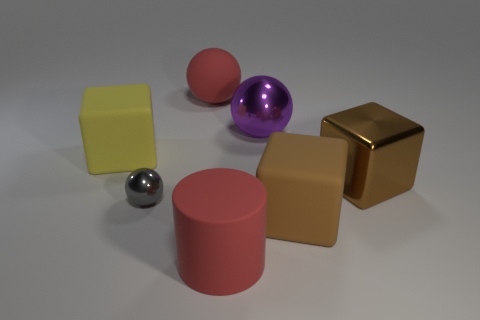Add 2 small things. How many objects exist? 9 Subtract all cylinders. How many objects are left? 6 Add 2 large green matte blocks. How many large green matte blocks exist? 2 Subtract 0 yellow cylinders. How many objects are left? 7 Subtract all small metallic things. Subtract all metal balls. How many objects are left? 4 Add 7 rubber blocks. How many rubber blocks are left? 9 